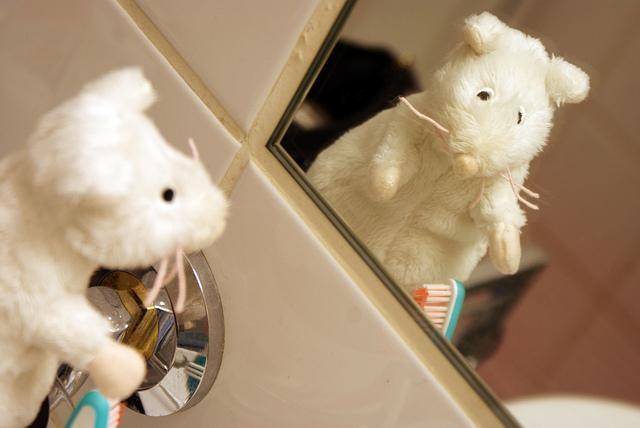How many stuffed animals?
Give a very brief answer. 1. 